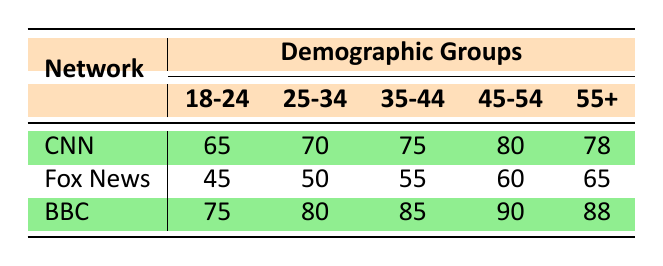What is CNN's credibility score for the 18-24 demographic group? The table shows that under the demographic group 18-24, CNN has a credibility score of 65.
Answer: 65 Which network has the highest credibility score in the 45-54 demographic group? The table indicates that the BBC has the highest credibility score in the 45-54 group with a score of 90, compared to CNN's 80 and Fox News's 60.
Answer: BBC What is the difference between the credibility scores of BBC and Fox News for the 35-44 demographic group? For the 35-44 age group, BBC has a score of 85 and Fox News has a score of 55. The difference is calculated as 85 - 55 = 30.
Answer: 30 Is the credibility score of CNN for the 55+ demographic group greater than that of Fox News? The table shows that CNN has a score of 78 for the 55+ group, while Fox News has a score of 65. Since 78 is greater than 65, the statement is true.
Answer: Yes What is the average credibility score of CNN across all demographic groups? The scores for CNN across all groups are 65, 70, 75, 80, and 78. Summing these scores gives 368. Dividing by the number of groups (5), the average is 368/5 = 73.6.
Answer: 73.6 Which demographic group shows the lowest credibility score for Fox News? Looking at the table, the lowest score for Fox News is in the 18-24 demographic group, where it has a score of 45.
Answer: 18-24 How does the credibility score of BBC in the 25-34 demographic compare to that of CNN in the same demographic? In the 25-34 demographic, BBC has a credibility score of 80, while CNN has a score of 70. Therefore, BBC's score is higher by 10 points.
Answer: 10 points higher Is the average credibility score of BBC across all groups above 85? The scores for BBC are 75, 80, 85, 90, and 88. Summing these gives 418, and dividing by 5 gives an average of 83.6, which is not above 85. Therefore, the statement is false.
Answer: No Which network has the most consistent credibility scores across demographic groups? By examining the scores, CNN's scores range from 65 to 80 (difference of 15), while Fox News ranges from 45 to 65 (difference of 20) and BBC ranges from 75 to 90 (difference of 15). Both CNN and BBC have the same consistency with a difference of 15. However, looking at the absolute scores and the overall perception, CNN is perceived more consistently.
Answer: CNN 